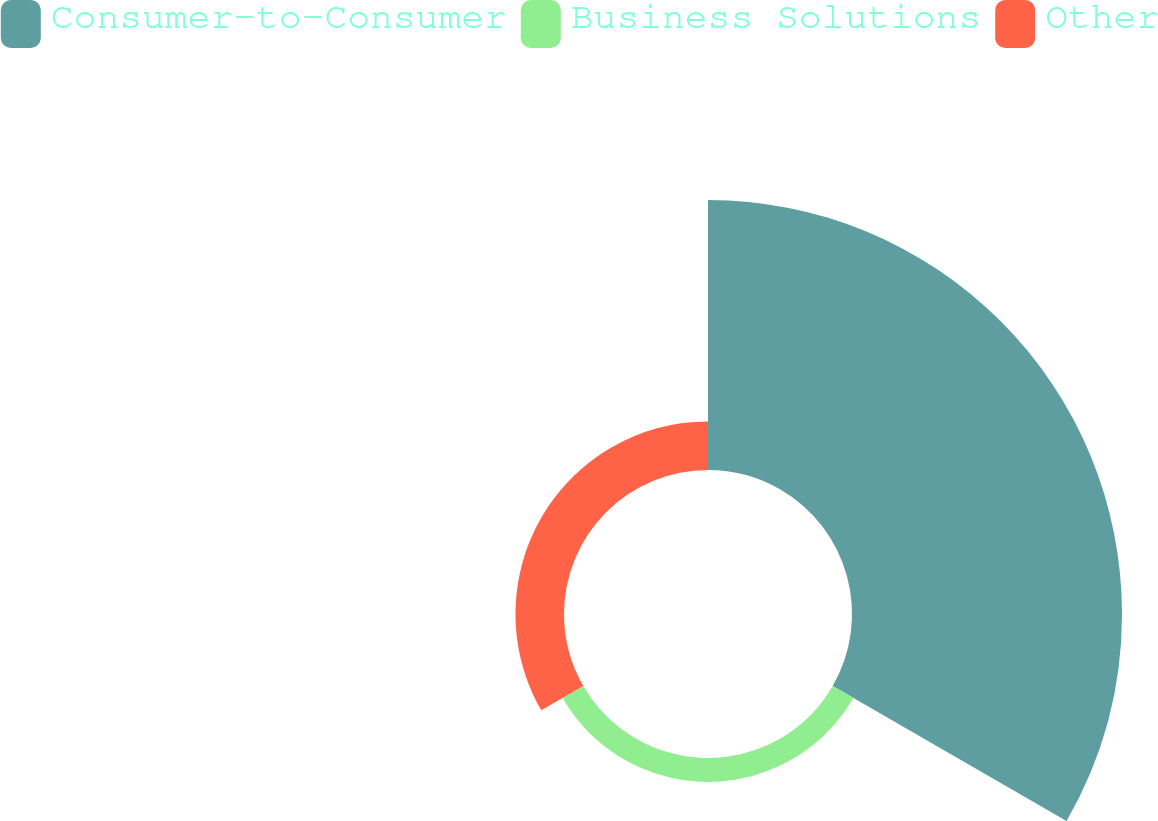Convert chart to OTSL. <chart><loc_0><loc_0><loc_500><loc_500><pie_chart><fcel>Consumer-to-Consumer<fcel>Business Solutions<fcel>Other<nl><fcel>78.84%<fcel>6.99%<fcel>14.17%<nl></chart> 